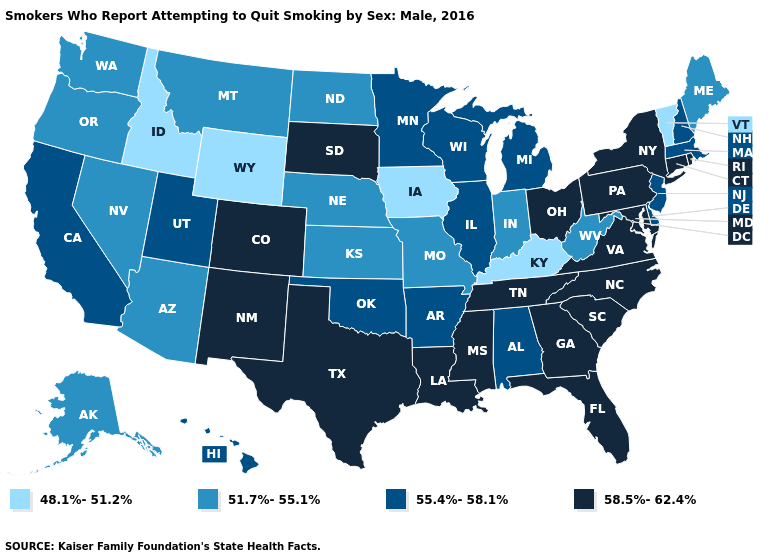Does Hawaii have the lowest value in the West?
Write a very short answer. No. Name the states that have a value in the range 51.7%-55.1%?
Write a very short answer. Alaska, Arizona, Indiana, Kansas, Maine, Missouri, Montana, Nebraska, Nevada, North Dakota, Oregon, Washington, West Virginia. Does Alaska have the highest value in the USA?
Quick response, please. No. Among the states that border Massachusetts , which have the highest value?
Quick response, please. Connecticut, New York, Rhode Island. What is the highest value in states that border New York?
Quick response, please. 58.5%-62.4%. Does Massachusetts have the lowest value in the USA?
Give a very brief answer. No. Among the states that border Louisiana , does Arkansas have the highest value?
Keep it brief. No. How many symbols are there in the legend?
Short answer required. 4. Which states hav the highest value in the South?
Short answer required. Florida, Georgia, Louisiana, Maryland, Mississippi, North Carolina, South Carolina, Tennessee, Texas, Virginia. Does New York have the highest value in the USA?
Quick response, please. Yes. Which states hav the highest value in the West?
Keep it brief. Colorado, New Mexico. What is the value of Florida?
Concise answer only. 58.5%-62.4%. Among the states that border Washington , which have the highest value?
Write a very short answer. Oregon. What is the value of Wyoming?
Write a very short answer. 48.1%-51.2%. Does New Mexico have a lower value than Connecticut?
Answer briefly. No. 